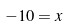<formula> <loc_0><loc_0><loc_500><loc_500>- 1 0 = x</formula> 